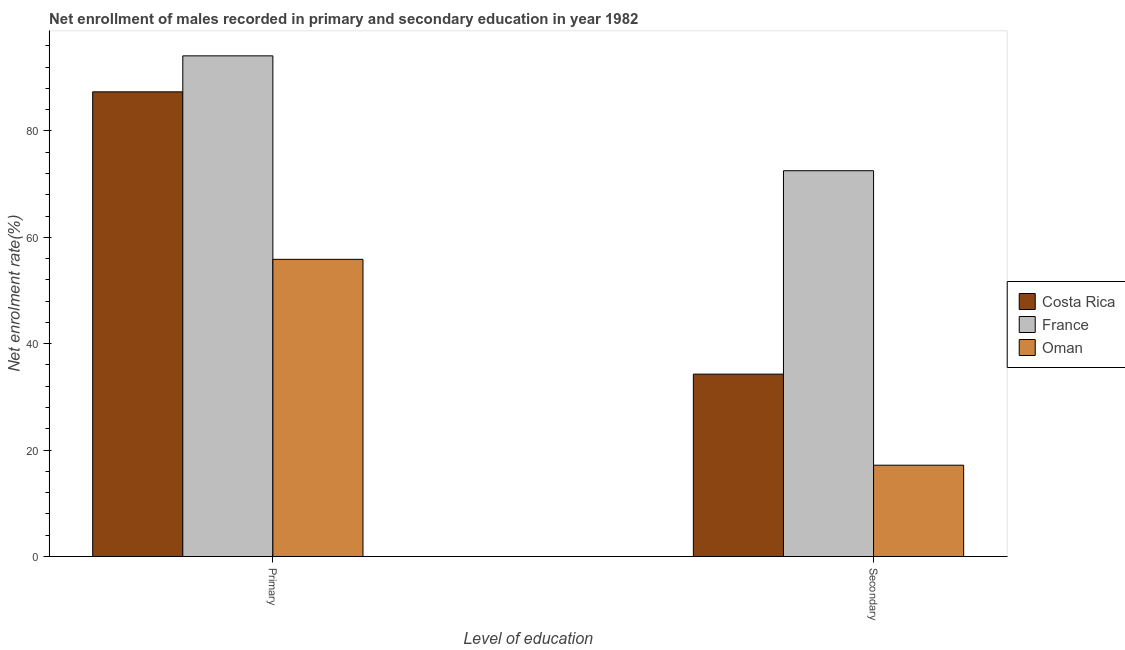How many different coloured bars are there?
Keep it short and to the point. 3. How many groups of bars are there?
Keep it short and to the point. 2. Are the number of bars on each tick of the X-axis equal?
Make the answer very short. Yes. What is the label of the 1st group of bars from the left?
Your answer should be compact. Primary. What is the enrollment rate in primary education in France?
Your response must be concise. 94.1. Across all countries, what is the maximum enrollment rate in secondary education?
Offer a very short reply. 72.51. Across all countries, what is the minimum enrollment rate in secondary education?
Provide a short and direct response. 17.16. In which country was the enrollment rate in primary education maximum?
Offer a terse response. France. In which country was the enrollment rate in primary education minimum?
Provide a short and direct response. Oman. What is the total enrollment rate in primary education in the graph?
Your answer should be compact. 237.29. What is the difference between the enrollment rate in primary education in Costa Rica and that in France?
Provide a short and direct response. -6.76. What is the difference between the enrollment rate in secondary education in Oman and the enrollment rate in primary education in France?
Ensure brevity in your answer.  -76.94. What is the average enrollment rate in secondary education per country?
Provide a short and direct response. 41.32. What is the difference between the enrollment rate in primary education and enrollment rate in secondary education in Costa Rica?
Make the answer very short. 53.05. In how many countries, is the enrollment rate in primary education greater than 92 %?
Provide a short and direct response. 1. What is the ratio of the enrollment rate in primary education in France to that in Oman?
Provide a short and direct response. 1.68. In how many countries, is the enrollment rate in primary education greater than the average enrollment rate in primary education taken over all countries?
Ensure brevity in your answer.  2. How many bars are there?
Offer a terse response. 6. Are all the bars in the graph horizontal?
Your answer should be compact. No. Does the graph contain grids?
Your answer should be very brief. No. How are the legend labels stacked?
Your answer should be compact. Vertical. What is the title of the graph?
Your response must be concise. Net enrollment of males recorded in primary and secondary education in year 1982. What is the label or title of the X-axis?
Offer a very short reply. Level of education. What is the label or title of the Y-axis?
Your answer should be very brief. Net enrolment rate(%). What is the Net enrolment rate(%) of Costa Rica in Primary?
Provide a short and direct response. 87.34. What is the Net enrolment rate(%) in France in Primary?
Ensure brevity in your answer.  94.1. What is the Net enrolment rate(%) in Oman in Primary?
Keep it short and to the point. 55.86. What is the Net enrolment rate(%) in Costa Rica in Secondary?
Ensure brevity in your answer.  34.28. What is the Net enrolment rate(%) in France in Secondary?
Keep it short and to the point. 72.51. What is the Net enrolment rate(%) in Oman in Secondary?
Make the answer very short. 17.16. Across all Level of education, what is the maximum Net enrolment rate(%) of Costa Rica?
Your answer should be compact. 87.34. Across all Level of education, what is the maximum Net enrolment rate(%) in France?
Make the answer very short. 94.1. Across all Level of education, what is the maximum Net enrolment rate(%) in Oman?
Your response must be concise. 55.86. Across all Level of education, what is the minimum Net enrolment rate(%) of Costa Rica?
Provide a succinct answer. 34.28. Across all Level of education, what is the minimum Net enrolment rate(%) of France?
Provide a short and direct response. 72.51. Across all Level of education, what is the minimum Net enrolment rate(%) of Oman?
Provide a short and direct response. 17.16. What is the total Net enrolment rate(%) of Costa Rica in the graph?
Offer a very short reply. 121.62. What is the total Net enrolment rate(%) in France in the graph?
Your answer should be compact. 166.61. What is the total Net enrolment rate(%) in Oman in the graph?
Offer a terse response. 73.02. What is the difference between the Net enrolment rate(%) of Costa Rica in Primary and that in Secondary?
Your response must be concise. 53.05. What is the difference between the Net enrolment rate(%) in France in Primary and that in Secondary?
Your answer should be compact. 21.59. What is the difference between the Net enrolment rate(%) of Oman in Primary and that in Secondary?
Ensure brevity in your answer.  38.69. What is the difference between the Net enrolment rate(%) in Costa Rica in Primary and the Net enrolment rate(%) in France in Secondary?
Offer a very short reply. 14.83. What is the difference between the Net enrolment rate(%) in Costa Rica in Primary and the Net enrolment rate(%) in Oman in Secondary?
Your answer should be compact. 70.17. What is the difference between the Net enrolment rate(%) of France in Primary and the Net enrolment rate(%) of Oman in Secondary?
Provide a succinct answer. 76.94. What is the average Net enrolment rate(%) in Costa Rica per Level of education?
Provide a succinct answer. 60.81. What is the average Net enrolment rate(%) in France per Level of education?
Ensure brevity in your answer.  83.31. What is the average Net enrolment rate(%) in Oman per Level of education?
Your answer should be compact. 36.51. What is the difference between the Net enrolment rate(%) in Costa Rica and Net enrolment rate(%) in France in Primary?
Give a very brief answer. -6.76. What is the difference between the Net enrolment rate(%) of Costa Rica and Net enrolment rate(%) of Oman in Primary?
Keep it short and to the point. 31.48. What is the difference between the Net enrolment rate(%) in France and Net enrolment rate(%) in Oman in Primary?
Keep it short and to the point. 38.24. What is the difference between the Net enrolment rate(%) in Costa Rica and Net enrolment rate(%) in France in Secondary?
Your answer should be very brief. -38.23. What is the difference between the Net enrolment rate(%) in Costa Rica and Net enrolment rate(%) in Oman in Secondary?
Offer a very short reply. 17.12. What is the difference between the Net enrolment rate(%) of France and Net enrolment rate(%) of Oman in Secondary?
Ensure brevity in your answer.  55.35. What is the ratio of the Net enrolment rate(%) in Costa Rica in Primary to that in Secondary?
Make the answer very short. 2.55. What is the ratio of the Net enrolment rate(%) in France in Primary to that in Secondary?
Your answer should be compact. 1.3. What is the ratio of the Net enrolment rate(%) of Oman in Primary to that in Secondary?
Your answer should be very brief. 3.25. What is the difference between the highest and the second highest Net enrolment rate(%) in Costa Rica?
Ensure brevity in your answer.  53.05. What is the difference between the highest and the second highest Net enrolment rate(%) of France?
Offer a very short reply. 21.59. What is the difference between the highest and the second highest Net enrolment rate(%) in Oman?
Keep it short and to the point. 38.69. What is the difference between the highest and the lowest Net enrolment rate(%) in Costa Rica?
Ensure brevity in your answer.  53.05. What is the difference between the highest and the lowest Net enrolment rate(%) in France?
Keep it short and to the point. 21.59. What is the difference between the highest and the lowest Net enrolment rate(%) of Oman?
Give a very brief answer. 38.69. 